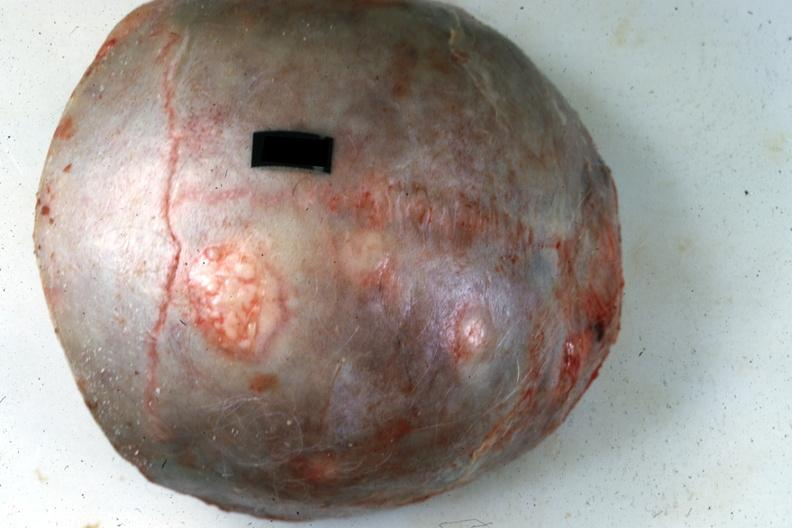s cervical leiomyoma present?
Answer the question using a single word or phrase. No 